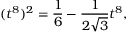<formula> <loc_0><loc_0><loc_500><loc_500>( t ^ { 8 } ) ^ { 2 } = \frac { 1 } { 6 } - \frac { 1 } { 2 \sqrt { 3 } } t ^ { 8 } ,</formula> 